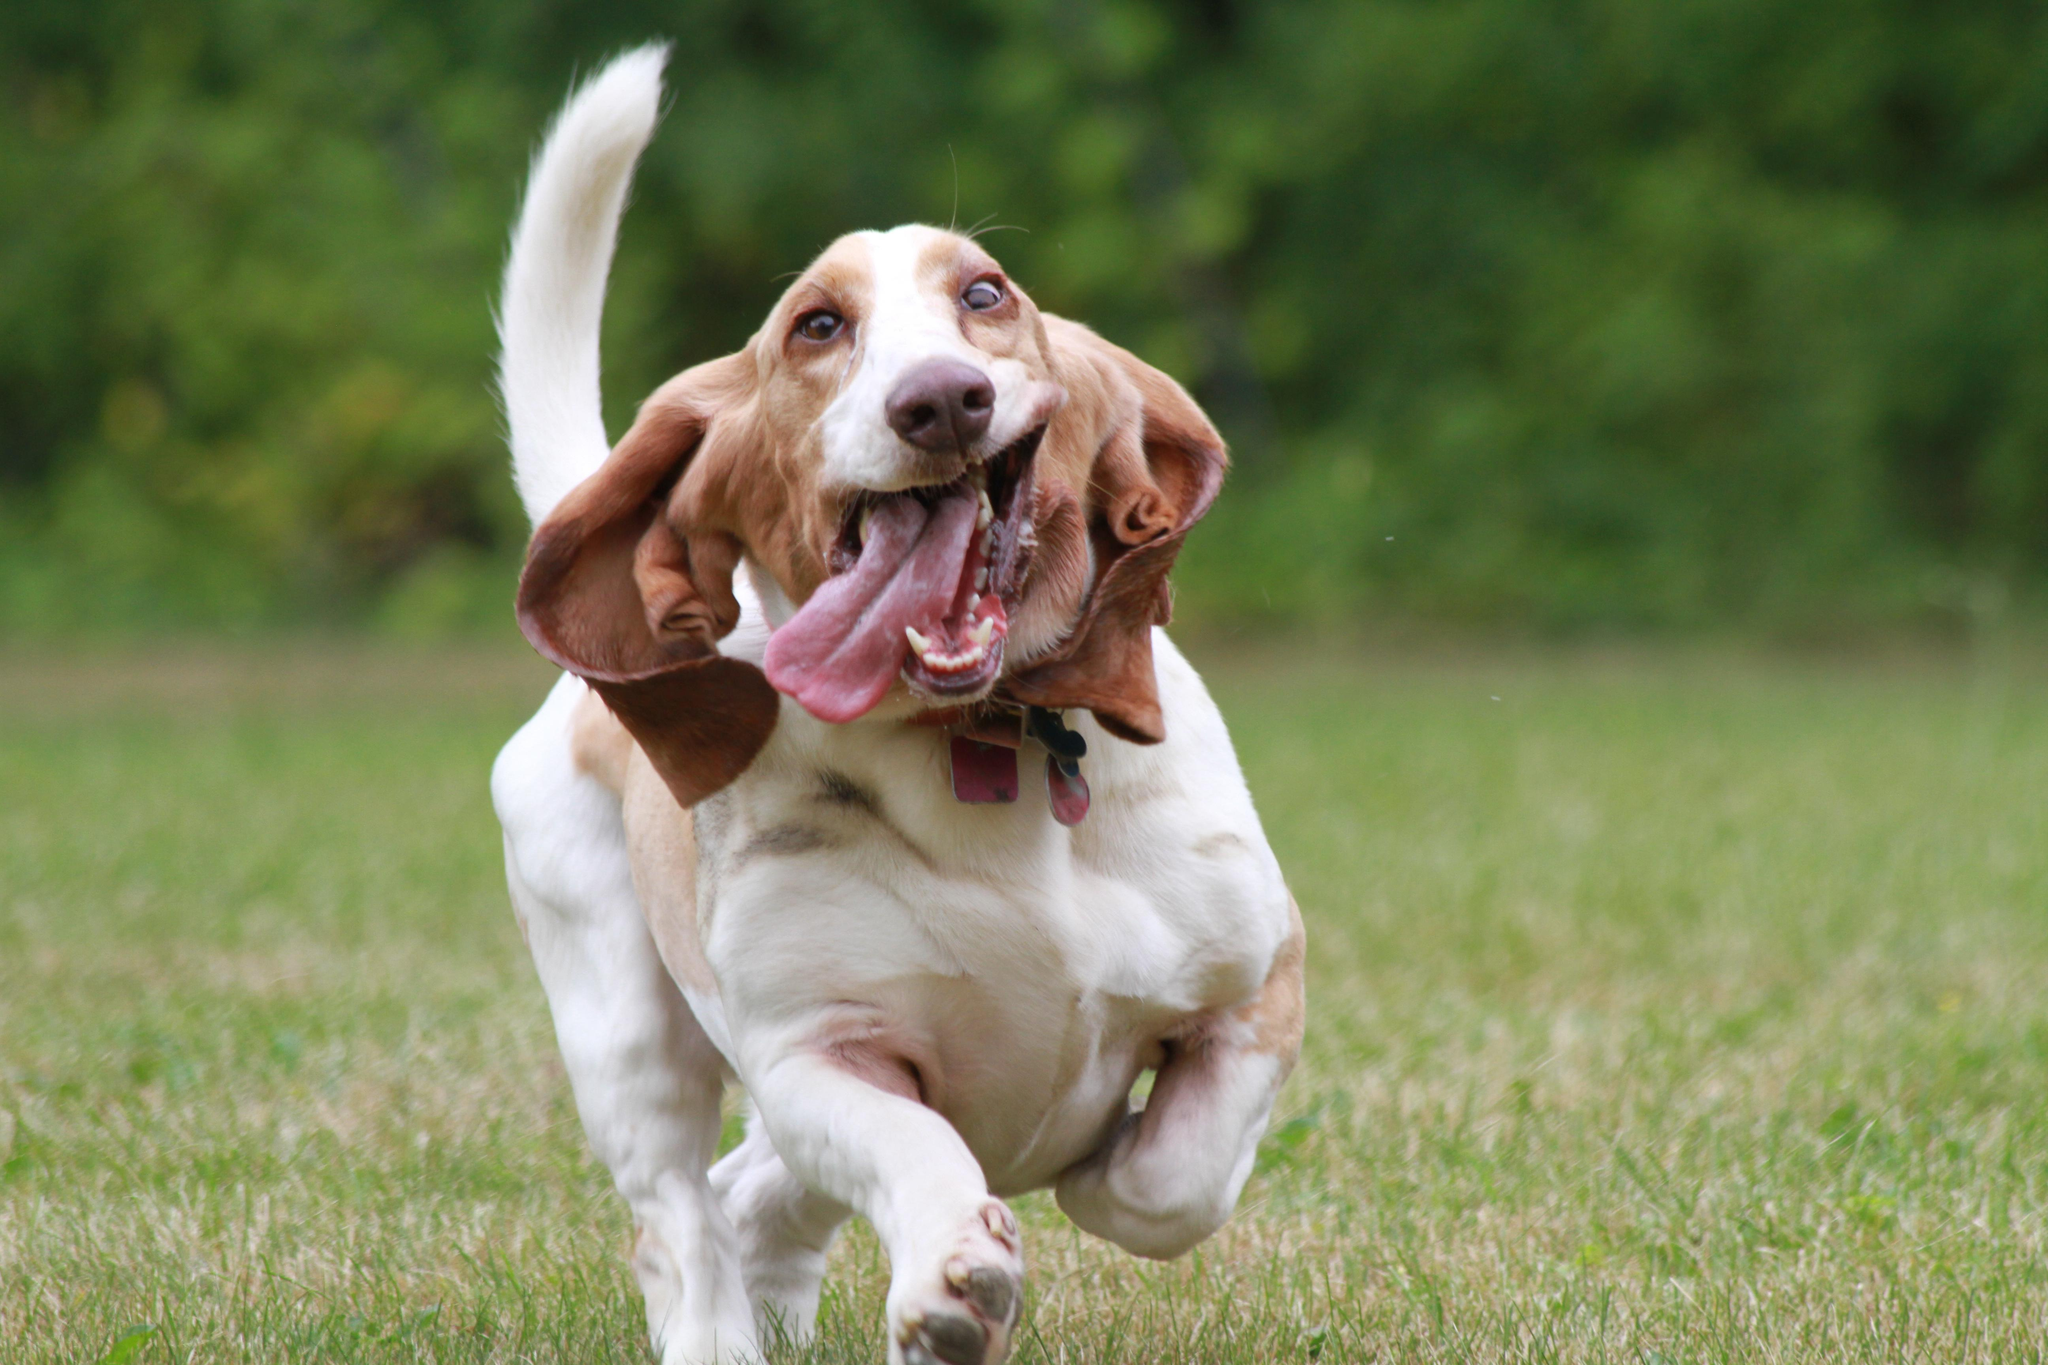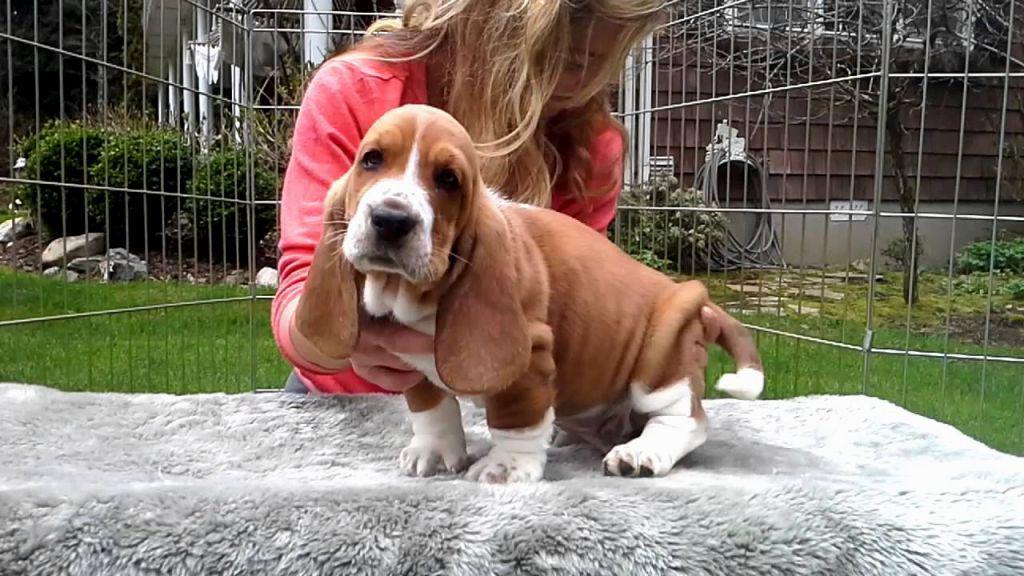The first image is the image on the left, the second image is the image on the right. Assess this claim about the two images: "The dog in the image on the left is sitting on grass.". Correct or not? Answer yes or no. No. The first image is the image on the left, the second image is the image on the right. For the images displayed, is the sentence "One image shows a basset hound sitting on furniture made for humans." factually correct? Answer yes or no. No. 